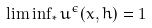Convert formula to latex. <formula><loc_0><loc_0><loc_500><loc_500>\liminf \nolimits _ { * } u ^ { \epsilon } ( x , h ) = 1</formula> 